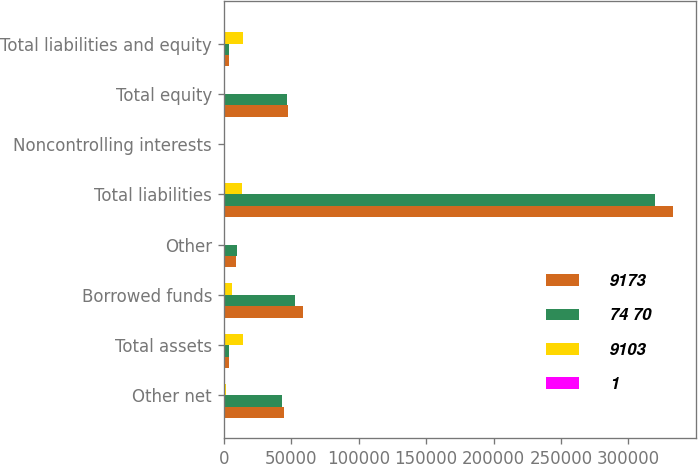Convert chart to OTSL. <chart><loc_0><loc_0><loc_500><loc_500><stacked_bar_chart><ecel><fcel>Other net<fcel>Total assets<fcel>Borrowed funds<fcel>Other<fcel>Total liabilities<fcel>Noncontrolling interests<fcel>Total equity<fcel>Total liabilities and equity<nl><fcel>9173<fcel>44535<fcel>3902<fcel>59088<fcel>9042<fcel>333183<fcel>72<fcel>47585<fcel>3902<nl><fcel>74 70<fcel>43113<fcel>3902<fcel>52706<fcel>9656<fcel>319526<fcel>1155<fcel>46854<fcel>3902<nl><fcel>9103<fcel>1422<fcel>14388<fcel>6382<fcel>614<fcel>13657<fcel>1083<fcel>731<fcel>14388<nl><fcel>1<fcel>3<fcel>4<fcel>12<fcel>6<fcel>4<fcel>94<fcel>2<fcel>4<nl></chart> 